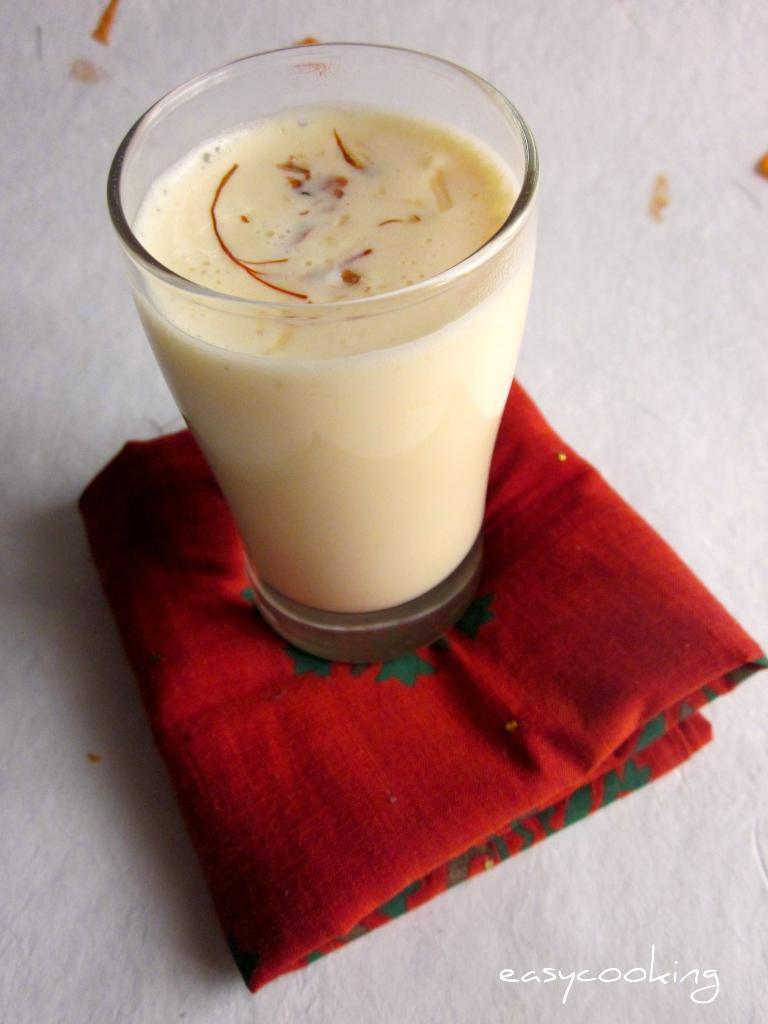What is contained in the glass that is visible in the image? There is a drink in the glass that is visible in the image. What is covering the object (likely a table) in the image? There is a cloth covering the object (likely a table) in the image. Where is the object (likely a table) located in the image? The object (likely a table) is at the bottom of the image. What can be read or seen at the bottom of the image? There is text visible at the bottom of the image. What is the aftermath of the trade deal in the image? There is no mention of a trade deal or any aftermath in the image; it only features a glass with a drink, a cloth-covered object (likely a table), and text at the bottom. 